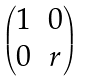Convert formula to latex. <formula><loc_0><loc_0><loc_500><loc_500>\begin{pmatrix} 1 & 0 \\ 0 & r \end{pmatrix}</formula> 